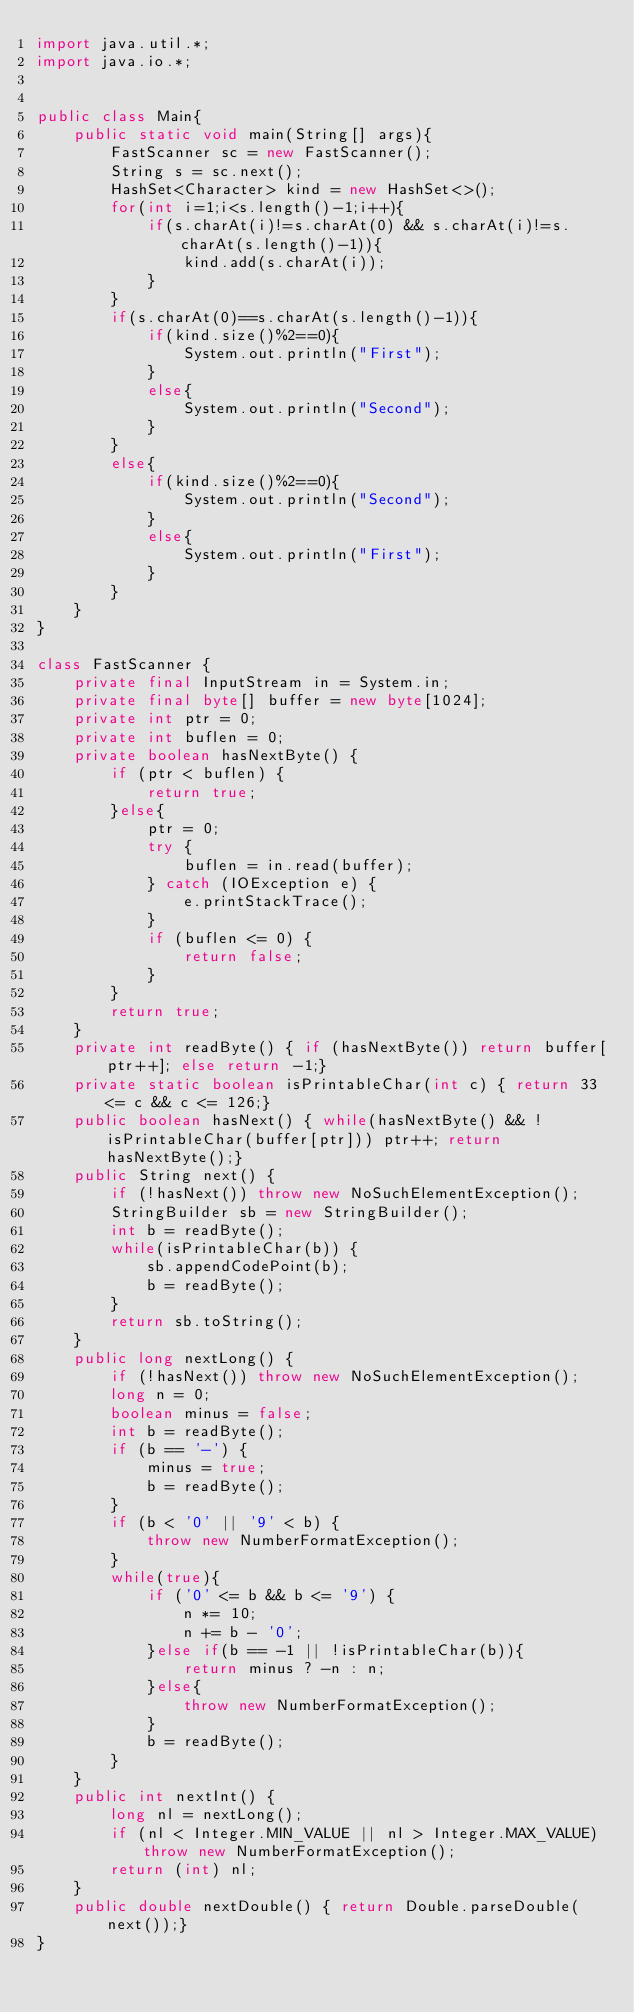Convert code to text. <code><loc_0><loc_0><loc_500><loc_500><_Java_>import java.util.*;
import java.io.*;


public class Main{
    public static void main(String[] args){
        FastScanner sc = new FastScanner();
        String s = sc.next();
        HashSet<Character> kind = new HashSet<>();
        for(int i=1;i<s.length()-1;i++){
            if(s.charAt(i)!=s.charAt(0) && s.charAt(i)!=s.charAt(s.length()-1)){
                kind.add(s.charAt(i));
            }
        }
        if(s.charAt(0)==s.charAt(s.length()-1)){
            if(kind.size()%2==0){
                System.out.println("First");
            }
            else{
                System.out.println("Second");
            }
        }
        else{
            if(kind.size()%2==0){
                System.out.println("Second");
            }
            else{
                System.out.println("First");
            }
        }
    }    
}

class FastScanner {
    private final InputStream in = System.in;
    private final byte[] buffer = new byte[1024];
    private int ptr = 0;
    private int buflen = 0;
    private boolean hasNextByte() {
        if (ptr < buflen) {
            return true;
        }else{
            ptr = 0;
            try {
                buflen = in.read(buffer);
            } catch (IOException e) {
                e.printStackTrace();
            }
            if (buflen <= 0) {
                return false;
            }
        }
        return true;
    }
    private int readByte() { if (hasNextByte()) return buffer[ptr++]; else return -1;}
    private static boolean isPrintableChar(int c) { return 33 <= c && c <= 126;}
    public boolean hasNext() { while(hasNextByte() && !isPrintableChar(buffer[ptr])) ptr++; return hasNextByte();}
    public String next() {
        if (!hasNext()) throw new NoSuchElementException();
        StringBuilder sb = new StringBuilder();
        int b = readByte();
        while(isPrintableChar(b)) {
            sb.appendCodePoint(b);
            b = readByte();
        }
        return sb.toString();
    }
    public long nextLong() {
        if (!hasNext()) throw new NoSuchElementException();
        long n = 0;
        boolean minus = false;
        int b = readByte();
        if (b == '-') {
            minus = true;
            b = readByte();
        }
        if (b < '0' || '9' < b) {
            throw new NumberFormatException();
        }
        while(true){
            if ('0' <= b && b <= '9') {
                n *= 10;
                n += b - '0';
            }else if(b == -1 || !isPrintableChar(b)){
                return minus ? -n : n;
            }else{
                throw new NumberFormatException();
            }
            b = readByte();
        }
    }
    public int nextInt() {
        long nl = nextLong();
        if (nl < Integer.MIN_VALUE || nl > Integer.MAX_VALUE) throw new NumberFormatException();
        return (int) nl;
    }
    public double nextDouble() { return Double.parseDouble(next());}
}</code> 